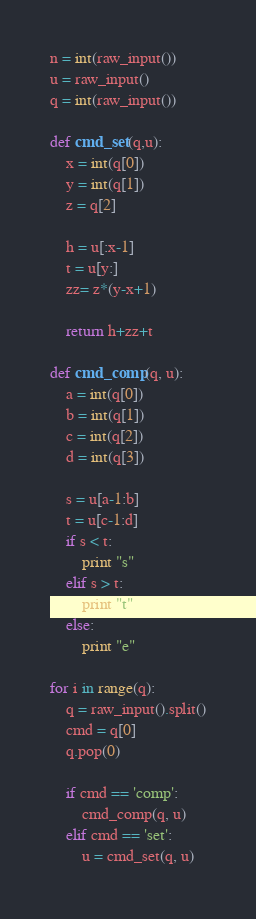Convert code to text. <code><loc_0><loc_0><loc_500><loc_500><_Python_>n = int(raw_input())
u = raw_input()
q = int(raw_input())

def cmd_set(q,u):
    x = int(q[0])
    y = int(q[1])
    z = q[2]

    h = u[:x-1]
    t = u[y:]
    zz= z*(y-x+1)

    return h+zz+t

def cmd_comp(q, u):
    a = int(q[0])
    b = int(q[1])
    c = int(q[2])
    d = int(q[3])

    s = u[a-1:b]
    t = u[c-1:d]
    if s < t:
        print "s"
    elif s > t:
        print "t"
    else:
        print "e"

for i in range(q):
    q = raw_input().split()
    cmd = q[0]
    q.pop(0)

    if cmd == 'comp':
        cmd_comp(q, u)
    elif cmd == 'set':
        u = cmd_set(q, u)</code> 